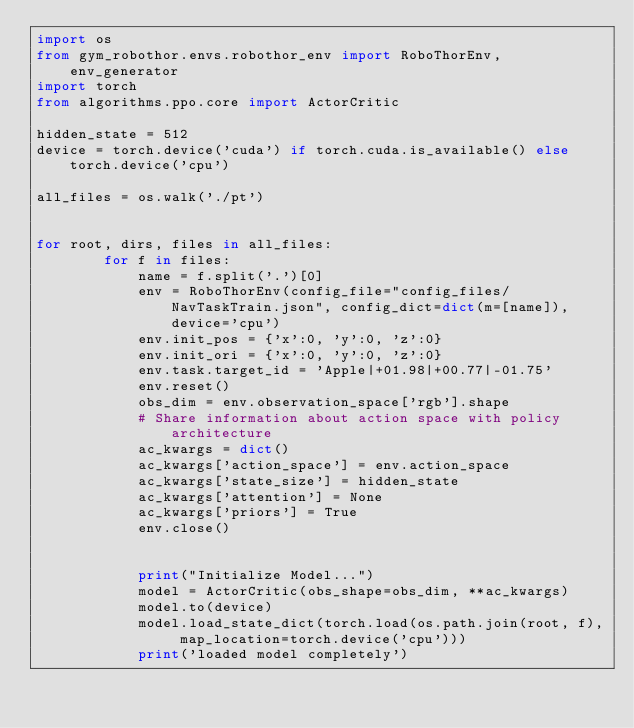<code> <loc_0><loc_0><loc_500><loc_500><_Python_>import os 
from gym_robothor.envs.robothor_env import RoboThorEnv, env_generator
import torch
from algorithms.ppo.core import ActorCritic

hidden_state = 512
device = torch.device('cuda') if torch.cuda.is_available() else torch.device('cpu')

all_files = os.walk('./pt')


for root, dirs, files in all_files:
        for f in files:
            name = f.split('.')[0]
            env = RoboThorEnv(config_file="config_files/NavTaskTrain.json", config_dict=dict(m=[name]), device='cpu')
            env.init_pos = {'x':0, 'y':0, 'z':0}
            env.init_ori = {'x':0, 'y':0, 'z':0}
            env.task.target_id = 'Apple|+01.98|+00.77|-01.75'
            env.reset()
            obs_dim = env.observation_space['rgb'].shape
            # Share information about action space with policy architecture
            ac_kwargs = dict()
            ac_kwargs['action_space'] = env.action_space
            ac_kwargs['state_size'] = hidden_state
            ac_kwargs['attention'] = None
            ac_kwargs['priors'] = True
            env.close()  
    

            print("Initialize Model...")
            model = ActorCritic(obs_shape=obs_dim, **ac_kwargs)
            model.to(device)
            model.load_state_dict(torch.load(os.path.join(root, f), map_location=torch.device('cpu')))
            print('loaded model completely')
</code> 